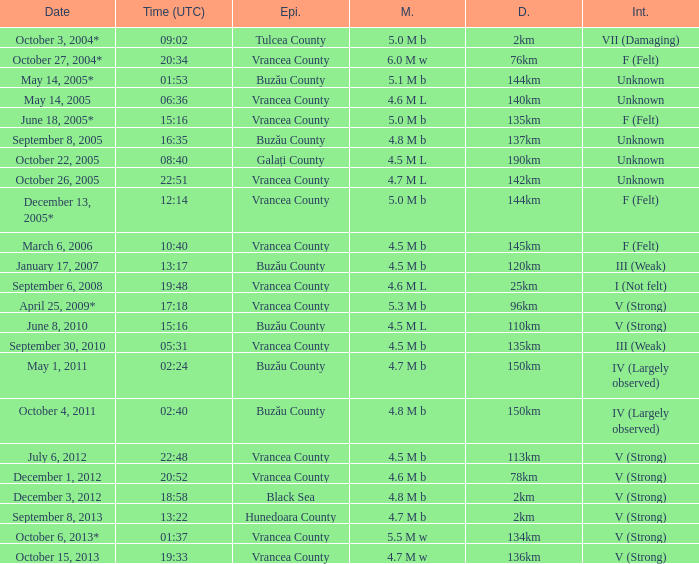What is the magnitude with epicenter at Vrancea County, unknown intensity and which happened at 06:36? 4.6 M L. 